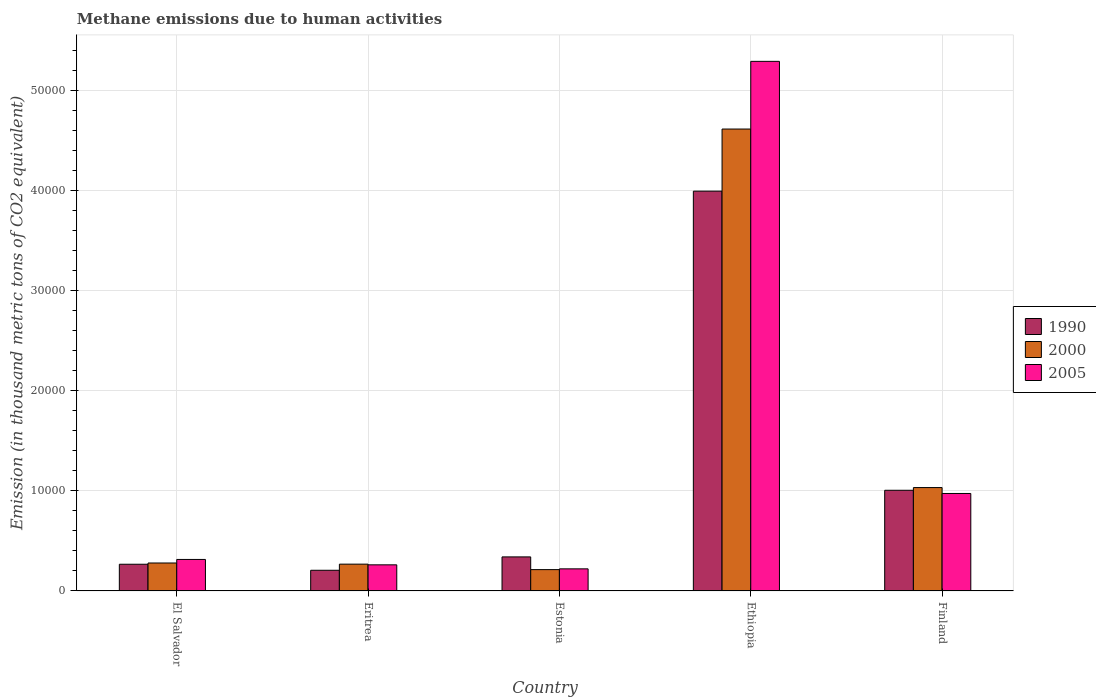How many different coloured bars are there?
Provide a succinct answer. 3. How many groups of bars are there?
Your answer should be compact. 5. Are the number of bars per tick equal to the number of legend labels?
Your answer should be very brief. Yes. How many bars are there on the 3rd tick from the left?
Your answer should be compact. 3. How many bars are there on the 3rd tick from the right?
Offer a terse response. 3. What is the label of the 5th group of bars from the left?
Give a very brief answer. Finland. In how many cases, is the number of bars for a given country not equal to the number of legend labels?
Offer a very short reply. 0. What is the amount of methane emitted in 2000 in El Salvador?
Give a very brief answer. 2798.1. Across all countries, what is the maximum amount of methane emitted in 2000?
Give a very brief answer. 4.62e+04. Across all countries, what is the minimum amount of methane emitted in 1990?
Offer a terse response. 2070.6. In which country was the amount of methane emitted in 1990 maximum?
Offer a very short reply. Ethiopia. In which country was the amount of methane emitted in 2000 minimum?
Your response must be concise. Estonia. What is the total amount of methane emitted in 2000 in the graph?
Keep it short and to the point. 6.41e+04. What is the difference between the amount of methane emitted in 2000 in El Salvador and that in Finland?
Ensure brevity in your answer.  -7542.7. What is the difference between the amount of methane emitted in 2005 in El Salvador and the amount of methane emitted in 2000 in Estonia?
Offer a terse response. 1016.5. What is the average amount of methane emitted in 1990 per country?
Provide a succinct answer. 1.16e+04. What is the difference between the amount of methane emitted of/in 2005 and amount of methane emitted of/in 2000 in Eritrea?
Offer a very short reply. -68.7. What is the ratio of the amount of methane emitted in 2000 in Estonia to that in Ethiopia?
Keep it short and to the point. 0.05. What is the difference between the highest and the second highest amount of methane emitted in 2005?
Give a very brief answer. -6597.2. What is the difference between the highest and the lowest amount of methane emitted in 1990?
Offer a very short reply. 3.79e+04. What does the 1st bar from the left in Estonia represents?
Give a very brief answer. 1990. Is it the case that in every country, the sum of the amount of methane emitted in 2000 and amount of methane emitted in 2005 is greater than the amount of methane emitted in 1990?
Your answer should be compact. Yes. How many bars are there?
Your answer should be compact. 15. Are all the bars in the graph horizontal?
Keep it short and to the point. No. What is the difference between two consecutive major ticks on the Y-axis?
Your response must be concise. 10000. Are the values on the major ticks of Y-axis written in scientific E-notation?
Give a very brief answer. No. Does the graph contain any zero values?
Offer a very short reply. No. Does the graph contain grids?
Your answer should be compact. Yes. How are the legend labels stacked?
Offer a terse response. Vertical. What is the title of the graph?
Offer a very short reply. Methane emissions due to human activities. Does "2000" appear as one of the legend labels in the graph?
Make the answer very short. Yes. What is the label or title of the Y-axis?
Your answer should be very brief. Emission (in thousand metric tons of CO2 equivalent). What is the Emission (in thousand metric tons of CO2 equivalent) of 1990 in El Salvador?
Your answer should be very brief. 2672.9. What is the Emission (in thousand metric tons of CO2 equivalent) in 2000 in El Salvador?
Offer a very short reply. 2798.1. What is the Emission (in thousand metric tons of CO2 equivalent) of 2005 in El Salvador?
Offer a terse response. 3152.8. What is the Emission (in thousand metric tons of CO2 equivalent) in 1990 in Eritrea?
Offer a very short reply. 2070.6. What is the Emission (in thousand metric tons of CO2 equivalent) in 2000 in Eritrea?
Offer a very short reply. 2682.3. What is the Emission (in thousand metric tons of CO2 equivalent) in 2005 in Eritrea?
Offer a very short reply. 2613.6. What is the Emission (in thousand metric tons of CO2 equivalent) of 1990 in Estonia?
Keep it short and to the point. 3408.3. What is the Emission (in thousand metric tons of CO2 equivalent) of 2000 in Estonia?
Provide a short and direct response. 2136.3. What is the Emission (in thousand metric tons of CO2 equivalent) in 2005 in Estonia?
Give a very brief answer. 2212.3. What is the Emission (in thousand metric tons of CO2 equivalent) of 1990 in Ethiopia?
Your answer should be very brief. 4.00e+04. What is the Emission (in thousand metric tons of CO2 equivalent) in 2000 in Ethiopia?
Offer a very short reply. 4.62e+04. What is the Emission (in thousand metric tons of CO2 equivalent) of 2005 in Ethiopia?
Your answer should be compact. 5.30e+04. What is the Emission (in thousand metric tons of CO2 equivalent) of 1990 in Finland?
Keep it short and to the point. 1.01e+04. What is the Emission (in thousand metric tons of CO2 equivalent) of 2000 in Finland?
Provide a succinct answer. 1.03e+04. What is the Emission (in thousand metric tons of CO2 equivalent) of 2005 in Finland?
Offer a very short reply. 9750. Across all countries, what is the maximum Emission (in thousand metric tons of CO2 equivalent) in 1990?
Provide a short and direct response. 4.00e+04. Across all countries, what is the maximum Emission (in thousand metric tons of CO2 equivalent) in 2000?
Your answer should be very brief. 4.62e+04. Across all countries, what is the maximum Emission (in thousand metric tons of CO2 equivalent) of 2005?
Make the answer very short. 5.30e+04. Across all countries, what is the minimum Emission (in thousand metric tons of CO2 equivalent) of 1990?
Ensure brevity in your answer.  2070.6. Across all countries, what is the minimum Emission (in thousand metric tons of CO2 equivalent) of 2000?
Your answer should be compact. 2136.3. Across all countries, what is the minimum Emission (in thousand metric tons of CO2 equivalent) in 2005?
Make the answer very short. 2212.3. What is the total Emission (in thousand metric tons of CO2 equivalent) of 1990 in the graph?
Your answer should be very brief. 5.82e+04. What is the total Emission (in thousand metric tons of CO2 equivalent) of 2000 in the graph?
Give a very brief answer. 6.41e+04. What is the total Emission (in thousand metric tons of CO2 equivalent) of 2005 in the graph?
Ensure brevity in your answer.  7.07e+04. What is the difference between the Emission (in thousand metric tons of CO2 equivalent) in 1990 in El Salvador and that in Eritrea?
Your answer should be compact. 602.3. What is the difference between the Emission (in thousand metric tons of CO2 equivalent) of 2000 in El Salvador and that in Eritrea?
Your response must be concise. 115.8. What is the difference between the Emission (in thousand metric tons of CO2 equivalent) of 2005 in El Salvador and that in Eritrea?
Your answer should be very brief. 539.2. What is the difference between the Emission (in thousand metric tons of CO2 equivalent) of 1990 in El Salvador and that in Estonia?
Your answer should be very brief. -735.4. What is the difference between the Emission (in thousand metric tons of CO2 equivalent) in 2000 in El Salvador and that in Estonia?
Your answer should be compact. 661.8. What is the difference between the Emission (in thousand metric tons of CO2 equivalent) of 2005 in El Salvador and that in Estonia?
Your answer should be compact. 940.5. What is the difference between the Emission (in thousand metric tons of CO2 equivalent) in 1990 in El Salvador and that in Ethiopia?
Give a very brief answer. -3.73e+04. What is the difference between the Emission (in thousand metric tons of CO2 equivalent) in 2000 in El Salvador and that in Ethiopia?
Make the answer very short. -4.34e+04. What is the difference between the Emission (in thousand metric tons of CO2 equivalent) in 2005 in El Salvador and that in Ethiopia?
Your answer should be compact. -4.98e+04. What is the difference between the Emission (in thousand metric tons of CO2 equivalent) in 1990 in El Salvador and that in Finland?
Provide a succinct answer. -7397.3. What is the difference between the Emission (in thousand metric tons of CO2 equivalent) of 2000 in El Salvador and that in Finland?
Provide a succinct answer. -7542.7. What is the difference between the Emission (in thousand metric tons of CO2 equivalent) in 2005 in El Salvador and that in Finland?
Your response must be concise. -6597.2. What is the difference between the Emission (in thousand metric tons of CO2 equivalent) in 1990 in Eritrea and that in Estonia?
Ensure brevity in your answer.  -1337.7. What is the difference between the Emission (in thousand metric tons of CO2 equivalent) of 2000 in Eritrea and that in Estonia?
Your response must be concise. 546. What is the difference between the Emission (in thousand metric tons of CO2 equivalent) of 2005 in Eritrea and that in Estonia?
Your response must be concise. 401.3. What is the difference between the Emission (in thousand metric tons of CO2 equivalent) of 1990 in Eritrea and that in Ethiopia?
Your response must be concise. -3.79e+04. What is the difference between the Emission (in thousand metric tons of CO2 equivalent) of 2000 in Eritrea and that in Ethiopia?
Make the answer very short. -4.35e+04. What is the difference between the Emission (in thousand metric tons of CO2 equivalent) of 2005 in Eritrea and that in Ethiopia?
Provide a succinct answer. -5.03e+04. What is the difference between the Emission (in thousand metric tons of CO2 equivalent) in 1990 in Eritrea and that in Finland?
Ensure brevity in your answer.  -7999.6. What is the difference between the Emission (in thousand metric tons of CO2 equivalent) in 2000 in Eritrea and that in Finland?
Offer a terse response. -7658.5. What is the difference between the Emission (in thousand metric tons of CO2 equivalent) of 2005 in Eritrea and that in Finland?
Provide a succinct answer. -7136.4. What is the difference between the Emission (in thousand metric tons of CO2 equivalent) in 1990 in Estonia and that in Ethiopia?
Offer a terse response. -3.66e+04. What is the difference between the Emission (in thousand metric tons of CO2 equivalent) of 2000 in Estonia and that in Ethiopia?
Your response must be concise. -4.41e+04. What is the difference between the Emission (in thousand metric tons of CO2 equivalent) of 2005 in Estonia and that in Ethiopia?
Keep it short and to the point. -5.07e+04. What is the difference between the Emission (in thousand metric tons of CO2 equivalent) of 1990 in Estonia and that in Finland?
Provide a short and direct response. -6661.9. What is the difference between the Emission (in thousand metric tons of CO2 equivalent) in 2000 in Estonia and that in Finland?
Provide a short and direct response. -8204.5. What is the difference between the Emission (in thousand metric tons of CO2 equivalent) of 2005 in Estonia and that in Finland?
Offer a very short reply. -7537.7. What is the difference between the Emission (in thousand metric tons of CO2 equivalent) in 1990 in Ethiopia and that in Finland?
Offer a very short reply. 2.99e+04. What is the difference between the Emission (in thousand metric tons of CO2 equivalent) of 2000 in Ethiopia and that in Finland?
Keep it short and to the point. 3.59e+04. What is the difference between the Emission (in thousand metric tons of CO2 equivalent) in 2005 in Ethiopia and that in Finland?
Provide a succinct answer. 4.32e+04. What is the difference between the Emission (in thousand metric tons of CO2 equivalent) of 1990 in El Salvador and the Emission (in thousand metric tons of CO2 equivalent) of 2000 in Eritrea?
Keep it short and to the point. -9.4. What is the difference between the Emission (in thousand metric tons of CO2 equivalent) in 1990 in El Salvador and the Emission (in thousand metric tons of CO2 equivalent) in 2005 in Eritrea?
Offer a very short reply. 59.3. What is the difference between the Emission (in thousand metric tons of CO2 equivalent) of 2000 in El Salvador and the Emission (in thousand metric tons of CO2 equivalent) of 2005 in Eritrea?
Your response must be concise. 184.5. What is the difference between the Emission (in thousand metric tons of CO2 equivalent) of 1990 in El Salvador and the Emission (in thousand metric tons of CO2 equivalent) of 2000 in Estonia?
Keep it short and to the point. 536.6. What is the difference between the Emission (in thousand metric tons of CO2 equivalent) in 1990 in El Salvador and the Emission (in thousand metric tons of CO2 equivalent) in 2005 in Estonia?
Provide a short and direct response. 460.6. What is the difference between the Emission (in thousand metric tons of CO2 equivalent) of 2000 in El Salvador and the Emission (in thousand metric tons of CO2 equivalent) of 2005 in Estonia?
Make the answer very short. 585.8. What is the difference between the Emission (in thousand metric tons of CO2 equivalent) of 1990 in El Salvador and the Emission (in thousand metric tons of CO2 equivalent) of 2000 in Ethiopia?
Provide a succinct answer. -4.35e+04. What is the difference between the Emission (in thousand metric tons of CO2 equivalent) of 1990 in El Salvador and the Emission (in thousand metric tons of CO2 equivalent) of 2005 in Ethiopia?
Offer a terse response. -5.03e+04. What is the difference between the Emission (in thousand metric tons of CO2 equivalent) in 2000 in El Salvador and the Emission (in thousand metric tons of CO2 equivalent) in 2005 in Ethiopia?
Keep it short and to the point. -5.02e+04. What is the difference between the Emission (in thousand metric tons of CO2 equivalent) in 1990 in El Salvador and the Emission (in thousand metric tons of CO2 equivalent) in 2000 in Finland?
Your answer should be very brief. -7667.9. What is the difference between the Emission (in thousand metric tons of CO2 equivalent) in 1990 in El Salvador and the Emission (in thousand metric tons of CO2 equivalent) in 2005 in Finland?
Your answer should be compact. -7077.1. What is the difference between the Emission (in thousand metric tons of CO2 equivalent) of 2000 in El Salvador and the Emission (in thousand metric tons of CO2 equivalent) of 2005 in Finland?
Keep it short and to the point. -6951.9. What is the difference between the Emission (in thousand metric tons of CO2 equivalent) in 1990 in Eritrea and the Emission (in thousand metric tons of CO2 equivalent) in 2000 in Estonia?
Provide a succinct answer. -65.7. What is the difference between the Emission (in thousand metric tons of CO2 equivalent) of 1990 in Eritrea and the Emission (in thousand metric tons of CO2 equivalent) of 2005 in Estonia?
Offer a very short reply. -141.7. What is the difference between the Emission (in thousand metric tons of CO2 equivalent) of 2000 in Eritrea and the Emission (in thousand metric tons of CO2 equivalent) of 2005 in Estonia?
Keep it short and to the point. 470. What is the difference between the Emission (in thousand metric tons of CO2 equivalent) in 1990 in Eritrea and the Emission (in thousand metric tons of CO2 equivalent) in 2000 in Ethiopia?
Your answer should be very brief. -4.41e+04. What is the difference between the Emission (in thousand metric tons of CO2 equivalent) of 1990 in Eritrea and the Emission (in thousand metric tons of CO2 equivalent) of 2005 in Ethiopia?
Make the answer very short. -5.09e+04. What is the difference between the Emission (in thousand metric tons of CO2 equivalent) in 2000 in Eritrea and the Emission (in thousand metric tons of CO2 equivalent) in 2005 in Ethiopia?
Ensure brevity in your answer.  -5.03e+04. What is the difference between the Emission (in thousand metric tons of CO2 equivalent) of 1990 in Eritrea and the Emission (in thousand metric tons of CO2 equivalent) of 2000 in Finland?
Provide a succinct answer. -8270.2. What is the difference between the Emission (in thousand metric tons of CO2 equivalent) of 1990 in Eritrea and the Emission (in thousand metric tons of CO2 equivalent) of 2005 in Finland?
Make the answer very short. -7679.4. What is the difference between the Emission (in thousand metric tons of CO2 equivalent) of 2000 in Eritrea and the Emission (in thousand metric tons of CO2 equivalent) of 2005 in Finland?
Your response must be concise. -7067.7. What is the difference between the Emission (in thousand metric tons of CO2 equivalent) of 1990 in Estonia and the Emission (in thousand metric tons of CO2 equivalent) of 2000 in Ethiopia?
Provide a succinct answer. -4.28e+04. What is the difference between the Emission (in thousand metric tons of CO2 equivalent) of 1990 in Estonia and the Emission (in thousand metric tons of CO2 equivalent) of 2005 in Ethiopia?
Your answer should be very brief. -4.96e+04. What is the difference between the Emission (in thousand metric tons of CO2 equivalent) in 2000 in Estonia and the Emission (in thousand metric tons of CO2 equivalent) in 2005 in Ethiopia?
Keep it short and to the point. -5.08e+04. What is the difference between the Emission (in thousand metric tons of CO2 equivalent) in 1990 in Estonia and the Emission (in thousand metric tons of CO2 equivalent) in 2000 in Finland?
Your answer should be compact. -6932.5. What is the difference between the Emission (in thousand metric tons of CO2 equivalent) in 1990 in Estonia and the Emission (in thousand metric tons of CO2 equivalent) in 2005 in Finland?
Offer a very short reply. -6341.7. What is the difference between the Emission (in thousand metric tons of CO2 equivalent) in 2000 in Estonia and the Emission (in thousand metric tons of CO2 equivalent) in 2005 in Finland?
Offer a very short reply. -7613.7. What is the difference between the Emission (in thousand metric tons of CO2 equivalent) of 1990 in Ethiopia and the Emission (in thousand metric tons of CO2 equivalent) of 2000 in Finland?
Your answer should be very brief. 2.96e+04. What is the difference between the Emission (in thousand metric tons of CO2 equivalent) of 1990 in Ethiopia and the Emission (in thousand metric tons of CO2 equivalent) of 2005 in Finland?
Give a very brief answer. 3.02e+04. What is the difference between the Emission (in thousand metric tons of CO2 equivalent) of 2000 in Ethiopia and the Emission (in thousand metric tons of CO2 equivalent) of 2005 in Finland?
Keep it short and to the point. 3.64e+04. What is the average Emission (in thousand metric tons of CO2 equivalent) of 1990 per country?
Provide a short and direct response. 1.16e+04. What is the average Emission (in thousand metric tons of CO2 equivalent) in 2000 per country?
Your answer should be very brief. 1.28e+04. What is the average Emission (in thousand metric tons of CO2 equivalent) of 2005 per country?
Keep it short and to the point. 1.41e+04. What is the difference between the Emission (in thousand metric tons of CO2 equivalent) in 1990 and Emission (in thousand metric tons of CO2 equivalent) in 2000 in El Salvador?
Your response must be concise. -125.2. What is the difference between the Emission (in thousand metric tons of CO2 equivalent) of 1990 and Emission (in thousand metric tons of CO2 equivalent) of 2005 in El Salvador?
Offer a very short reply. -479.9. What is the difference between the Emission (in thousand metric tons of CO2 equivalent) of 2000 and Emission (in thousand metric tons of CO2 equivalent) of 2005 in El Salvador?
Your response must be concise. -354.7. What is the difference between the Emission (in thousand metric tons of CO2 equivalent) of 1990 and Emission (in thousand metric tons of CO2 equivalent) of 2000 in Eritrea?
Your answer should be compact. -611.7. What is the difference between the Emission (in thousand metric tons of CO2 equivalent) in 1990 and Emission (in thousand metric tons of CO2 equivalent) in 2005 in Eritrea?
Offer a very short reply. -543. What is the difference between the Emission (in thousand metric tons of CO2 equivalent) of 2000 and Emission (in thousand metric tons of CO2 equivalent) of 2005 in Eritrea?
Ensure brevity in your answer.  68.7. What is the difference between the Emission (in thousand metric tons of CO2 equivalent) of 1990 and Emission (in thousand metric tons of CO2 equivalent) of 2000 in Estonia?
Make the answer very short. 1272. What is the difference between the Emission (in thousand metric tons of CO2 equivalent) of 1990 and Emission (in thousand metric tons of CO2 equivalent) of 2005 in Estonia?
Provide a succinct answer. 1196. What is the difference between the Emission (in thousand metric tons of CO2 equivalent) in 2000 and Emission (in thousand metric tons of CO2 equivalent) in 2005 in Estonia?
Your response must be concise. -76. What is the difference between the Emission (in thousand metric tons of CO2 equivalent) of 1990 and Emission (in thousand metric tons of CO2 equivalent) of 2000 in Ethiopia?
Give a very brief answer. -6210.5. What is the difference between the Emission (in thousand metric tons of CO2 equivalent) of 1990 and Emission (in thousand metric tons of CO2 equivalent) of 2005 in Ethiopia?
Your answer should be very brief. -1.30e+04. What is the difference between the Emission (in thousand metric tons of CO2 equivalent) in 2000 and Emission (in thousand metric tons of CO2 equivalent) in 2005 in Ethiopia?
Ensure brevity in your answer.  -6767.8. What is the difference between the Emission (in thousand metric tons of CO2 equivalent) of 1990 and Emission (in thousand metric tons of CO2 equivalent) of 2000 in Finland?
Provide a short and direct response. -270.6. What is the difference between the Emission (in thousand metric tons of CO2 equivalent) in 1990 and Emission (in thousand metric tons of CO2 equivalent) in 2005 in Finland?
Your response must be concise. 320.2. What is the difference between the Emission (in thousand metric tons of CO2 equivalent) of 2000 and Emission (in thousand metric tons of CO2 equivalent) of 2005 in Finland?
Keep it short and to the point. 590.8. What is the ratio of the Emission (in thousand metric tons of CO2 equivalent) in 1990 in El Salvador to that in Eritrea?
Make the answer very short. 1.29. What is the ratio of the Emission (in thousand metric tons of CO2 equivalent) in 2000 in El Salvador to that in Eritrea?
Your answer should be very brief. 1.04. What is the ratio of the Emission (in thousand metric tons of CO2 equivalent) of 2005 in El Salvador to that in Eritrea?
Make the answer very short. 1.21. What is the ratio of the Emission (in thousand metric tons of CO2 equivalent) of 1990 in El Salvador to that in Estonia?
Your answer should be compact. 0.78. What is the ratio of the Emission (in thousand metric tons of CO2 equivalent) in 2000 in El Salvador to that in Estonia?
Ensure brevity in your answer.  1.31. What is the ratio of the Emission (in thousand metric tons of CO2 equivalent) of 2005 in El Salvador to that in Estonia?
Provide a succinct answer. 1.43. What is the ratio of the Emission (in thousand metric tons of CO2 equivalent) of 1990 in El Salvador to that in Ethiopia?
Provide a succinct answer. 0.07. What is the ratio of the Emission (in thousand metric tons of CO2 equivalent) in 2000 in El Salvador to that in Ethiopia?
Make the answer very short. 0.06. What is the ratio of the Emission (in thousand metric tons of CO2 equivalent) of 2005 in El Salvador to that in Ethiopia?
Offer a very short reply. 0.06. What is the ratio of the Emission (in thousand metric tons of CO2 equivalent) in 1990 in El Salvador to that in Finland?
Your answer should be compact. 0.27. What is the ratio of the Emission (in thousand metric tons of CO2 equivalent) in 2000 in El Salvador to that in Finland?
Provide a succinct answer. 0.27. What is the ratio of the Emission (in thousand metric tons of CO2 equivalent) of 2005 in El Salvador to that in Finland?
Offer a terse response. 0.32. What is the ratio of the Emission (in thousand metric tons of CO2 equivalent) of 1990 in Eritrea to that in Estonia?
Offer a very short reply. 0.61. What is the ratio of the Emission (in thousand metric tons of CO2 equivalent) of 2000 in Eritrea to that in Estonia?
Provide a short and direct response. 1.26. What is the ratio of the Emission (in thousand metric tons of CO2 equivalent) in 2005 in Eritrea to that in Estonia?
Your answer should be compact. 1.18. What is the ratio of the Emission (in thousand metric tons of CO2 equivalent) of 1990 in Eritrea to that in Ethiopia?
Ensure brevity in your answer.  0.05. What is the ratio of the Emission (in thousand metric tons of CO2 equivalent) of 2000 in Eritrea to that in Ethiopia?
Make the answer very short. 0.06. What is the ratio of the Emission (in thousand metric tons of CO2 equivalent) of 2005 in Eritrea to that in Ethiopia?
Offer a terse response. 0.05. What is the ratio of the Emission (in thousand metric tons of CO2 equivalent) of 1990 in Eritrea to that in Finland?
Offer a very short reply. 0.21. What is the ratio of the Emission (in thousand metric tons of CO2 equivalent) of 2000 in Eritrea to that in Finland?
Provide a succinct answer. 0.26. What is the ratio of the Emission (in thousand metric tons of CO2 equivalent) in 2005 in Eritrea to that in Finland?
Your answer should be compact. 0.27. What is the ratio of the Emission (in thousand metric tons of CO2 equivalent) of 1990 in Estonia to that in Ethiopia?
Make the answer very short. 0.09. What is the ratio of the Emission (in thousand metric tons of CO2 equivalent) of 2000 in Estonia to that in Ethiopia?
Give a very brief answer. 0.05. What is the ratio of the Emission (in thousand metric tons of CO2 equivalent) in 2005 in Estonia to that in Ethiopia?
Give a very brief answer. 0.04. What is the ratio of the Emission (in thousand metric tons of CO2 equivalent) of 1990 in Estonia to that in Finland?
Make the answer very short. 0.34. What is the ratio of the Emission (in thousand metric tons of CO2 equivalent) of 2000 in Estonia to that in Finland?
Provide a succinct answer. 0.21. What is the ratio of the Emission (in thousand metric tons of CO2 equivalent) in 2005 in Estonia to that in Finland?
Ensure brevity in your answer.  0.23. What is the ratio of the Emission (in thousand metric tons of CO2 equivalent) in 1990 in Ethiopia to that in Finland?
Your response must be concise. 3.97. What is the ratio of the Emission (in thousand metric tons of CO2 equivalent) of 2000 in Ethiopia to that in Finland?
Ensure brevity in your answer.  4.47. What is the ratio of the Emission (in thousand metric tons of CO2 equivalent) in 2005 in Ethiopia to that in Finland?
Provide a succinct answer. 5.43. What is the difference between the highest and the second highest Emission (in thousand metric tons of CO2 equivalent) in 1990?
Your response must be concise. 2.99e+04. What is the difference between the highest and the second highest Emission (in thousand metric tons of CO2 equivalent) in 2000?
Your response must be concise. 3.59e+04. What is the difference between the highest and the second highest Emission (in thousand metric tons of CO2 equivalent) in 2005?
Make the answer very short. 4.32e+04. What is the difference between the highest and the lowest Emission (in thousand metric tons of CO2 equivalent) in 1990?
Give a very brief answer. 3.79e+04. What is the difference between the highest and the lowest Emission (in thousand metric tons of CO2 equivalent) of 2000?
Offer a very short reply. 4.41e+04. What is the difference between the highest and the lowest Emission (in thousand metric tons of CO2 equivalent) of 2005?
Your answer should be very brief. 5.07e+04. 